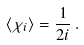Convert formula to latex. <formula><loc_0><loc_0><loc_500><loc_500>\langle \chi _ { i } \rangle = \frac { 1 } { 2 i } \, .</formula> 